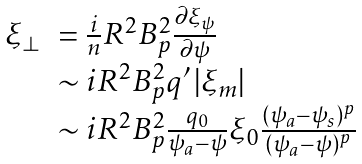Convert formula to latex. <formula><loc_0><loc_0><loc_500><loc_500>\begin{array} { l l } \xi _ { \perp } & = \frac { i } { n } R ^ { 2 } B _ { p } ^ { 2 } \frac { \partial \xi _ { \psi } } { \partial \psi } \\ & \sim i R ^ { 2 } B _ { p } ^ { 2 } q ^ { \prime } \left | \xi _ { m } \right | \\ & \sim i R ^ { 2 } B _ { p } ^ { 2 } \frac { q _ { 0 } } { \psi _ { a } - \psi } \xi _ { 0 } \frac { ( \psi _ { a } - \psi _ { s } ) ^ { p } } { ( \psi _ { a } - \psi ) ^ { p } } \end{array}</formula> 